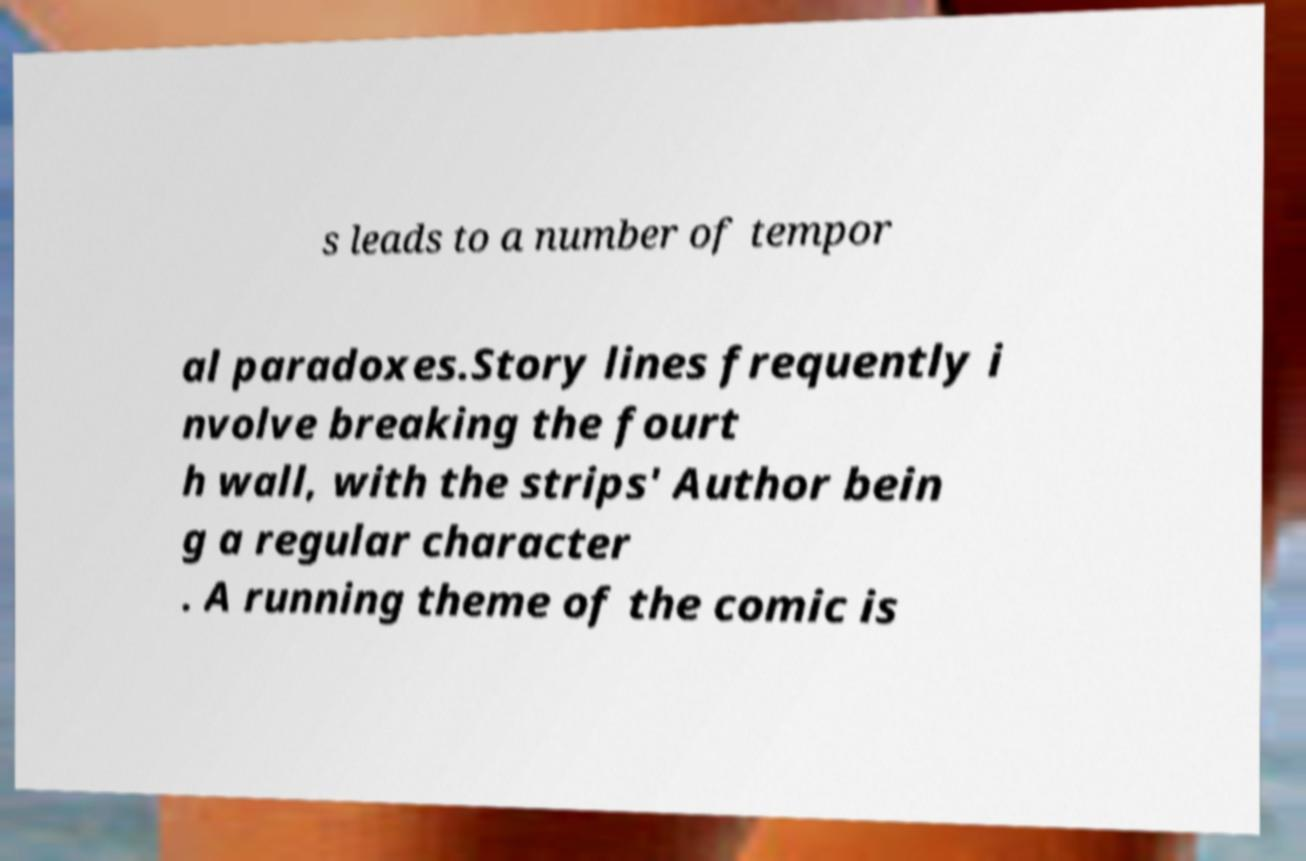Please identify and transcribe the text found in this image. s leads to a number of tempor al paradoxes.Story lines frequently i nvolve breaking the fourt h wall, with the strips' Author bein g a regular character . A running theme of the comic is 